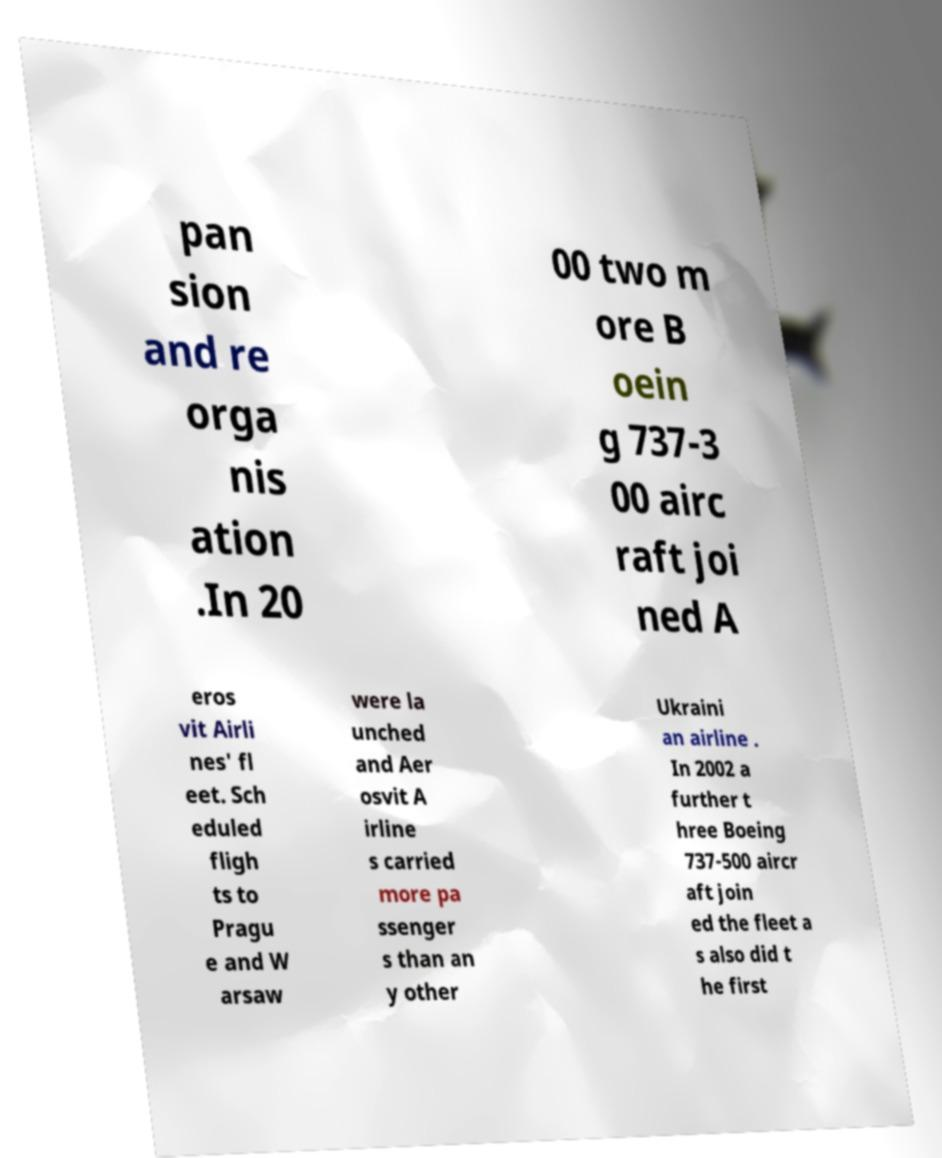Please read and relay the text visible in this image. What does it say? pan sion and re orga nis ation .In 20 00 two m ore B oein g 737-3 00 airc raft joi ned A eros vit Airli nes' fl eet. Sch eduled fligh ts to Pragu e and W arsaw were la unched and Aer osvit A irline s carried more pa ssenger s than an y other Ukraini an airline . In 2002 a further t hree Boeing 737-500 aircr aft join ed the fleet a s also did t he first 